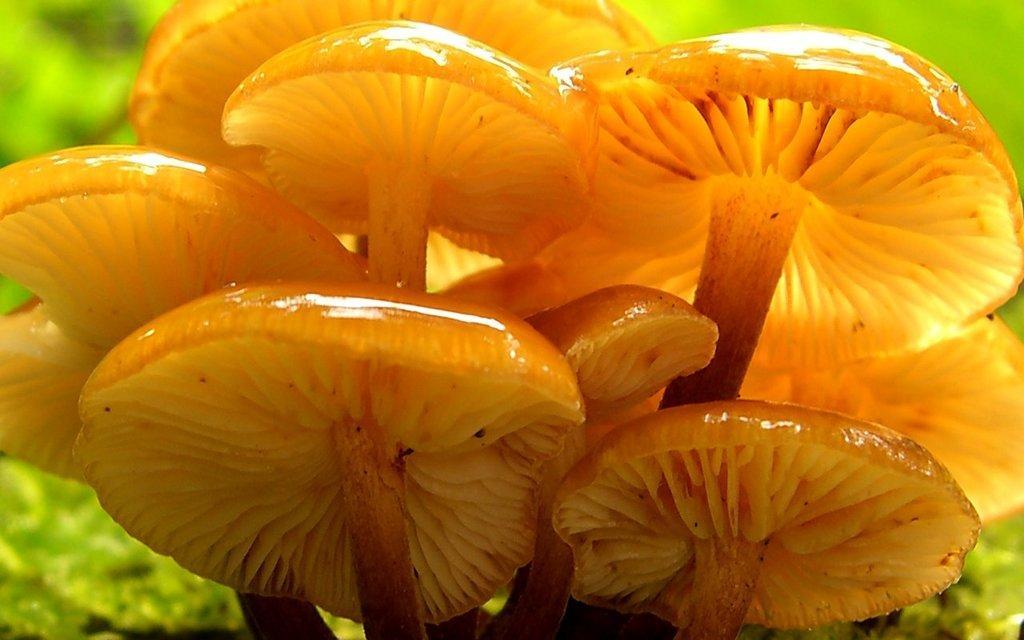Could you give a brief overview of what you see in this image? In the image in the center, we can see mushrooms, which are in orange color. 